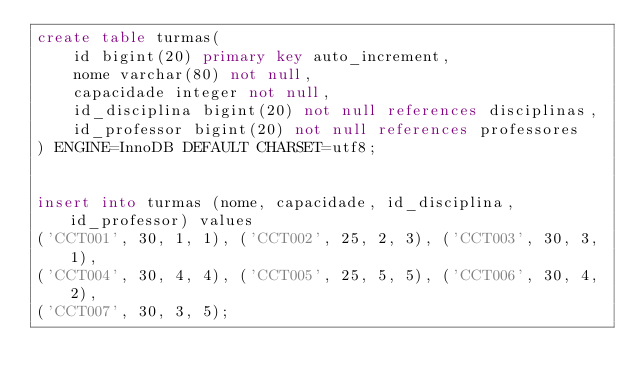Convert code to text. <code><loc_0><loc_0><loc_500><loc_500><_SQL_>create table turmas(
    id bigint(20) primary key auto_increment,
    nome varchar(80) not null,
    capacidade integer not null,
    id_disciplina bigint(20) not null references disciplinas,
    id_professor bigint(20) not null references professores
) ENGINE=InnoDB DEFAULT CHARSET=utf8;


insert into turmas (nome, capacidade, id_disciplina, id_professor) values
('CCT001', 30, 1, 1), ('CCT002', 25, 2, 3), ('CCT003', 30, 3, 1),
('CCT004', 30, 4, 4), ('CCT005', 25, 5, 5), ('CCT006', 30, 4, 2),
('CCT007', 30, 3, 5);</code> 